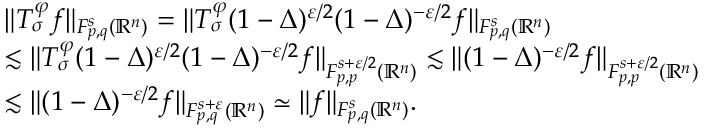<formula> <loc_0><loc_0><loc_500><loc_500>\begin{array} { r l } & { \| T _ { \sigma } ^ { \varphi } f \| _ { F _ { p , q } ^ { s } ( \mathbb { R } ^ { n } ) } = \| T _ { \sigma } ^ { \varphi } ( 1 - \Delta ) ^ { \varepsilon / 2 } ( 1 - \Delta ) ^ { - \varepsilon / 2 } f \| _ { F _ { p , q } ^ { s } ( \mathbb { R } ^ { n } ) } } \\ & { \lesssim \| T _ { \sigma } ^ { \varphi } ( 1 - \Delta ) ^ { \varepsilon / 2 } ( 1 - \Delta ) ^ { - \varepsilon / 2 } f \| _ { F _ { p , p } ^ { s + \varepsilon / 2 } ( \mathbb { R } ^ { n } ) } \lesssim \| ( 1 - \Delta ) ^ { - \varepsilon / 2 } f \| _ { F _ { p , p } ^ { s + \varepsilon / 2 } ( \mathbb { R } ^ { n } ) } } \\ & { \lesssim \| ( 1 - \Delta ) ^ { - \varepsilon / 2 } f \| _ { F _ { p , q } ^ { s + \varepsilon } ( \mathbb { R } ^ { n } ) } \simeq \| f \| _ { F _ { p , q } ^ { s } ( \mathbb { R } ^ { n } ) } . } \end{array}</formula> 